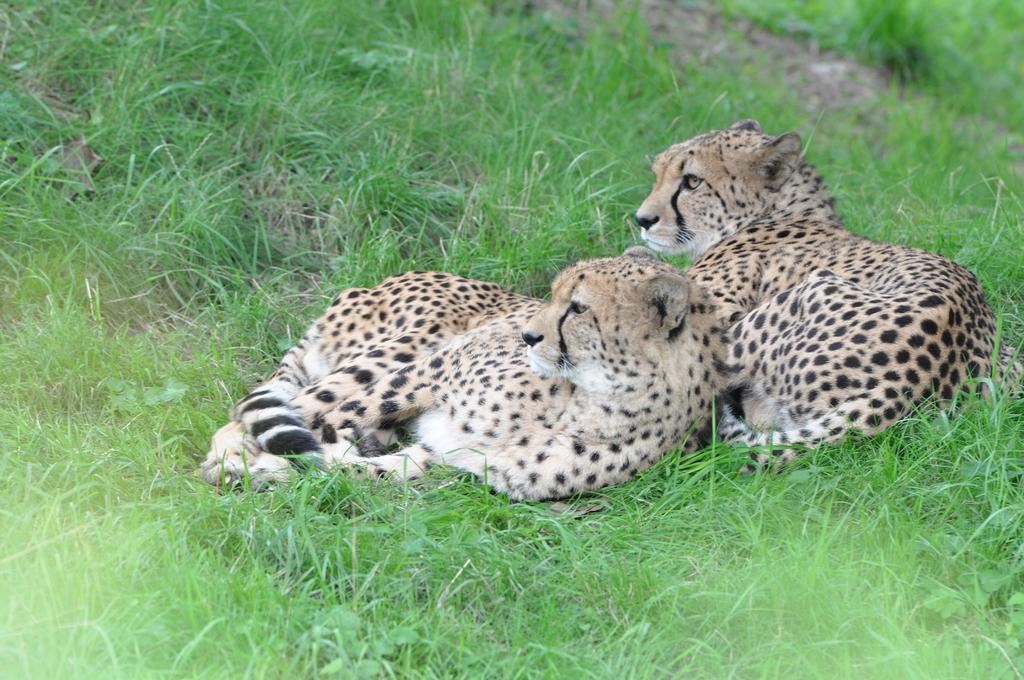How would you summarize this image in a sentence or two? In this image in the front there is grass on the ground and there are animals sitting on the ground. 